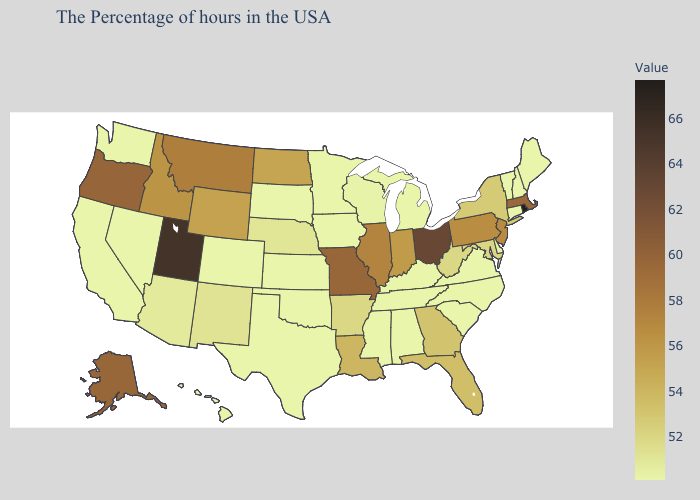Among the states that border Delaware , does Maryland have the highest value?
Quick response, please. No. Which states have the lowest value in the USA?
Keep it brief. Maine, New Hampshire, Vermont, Connecticut, Virginia, North Carolina, South Carolina, Michigan, Kentucky, Alabama, Tennessee, Mississippi, Minnesota, Iowa, Kansas, Oklahoma, Texas, South Dakota, Colorado, Nevada, California, Washington, Hawaii. Does Nevada have the highest value in the USA?
Write a very short answer. No. Which states have the highest value in the USA?
Write a very short answer. Rhode Island. Among the states that border Idaho , does Utah have the highest value?
Quick response, please. Yes. Does the map have missing data?
Keep it brief. No. 